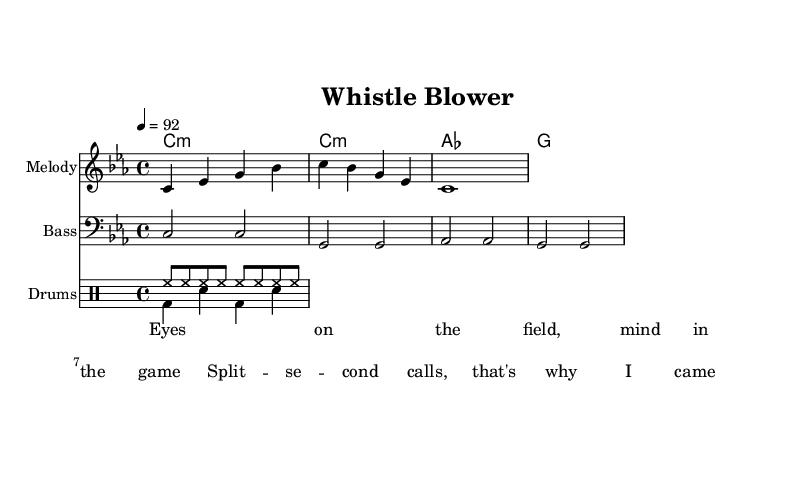What is the key signature of this music? The key signature indicates that the music is in C minor, as it is marked by the signature at the beginning with three flats (B flat, E flat, and A flat).
Answer: C minor What is the time signature of the piece? The time signature shows that the piece is written in 4/4 time, meaning there are four beats per measure, and the quarter note gets one beat. This is visible at the beginning of the music with the "4/4" notation.
Answer: 4/4 What is the tempo marking of the song? The tempo marking states that the piece should be played at a pace of 92 beats per minute. This is specified with "4 = 92" near the top of the sheet music.
Answer: 92 How many measures are in the melody section? The melody section comprises four measures, which can be counted by looking at the vertical lines separating the groupings of the notes in the sheet music.
Answer: 4 Which instrument plays the melody? The instrument specified to play the melody is labeled "Melody" at the beginning of its staff. This indicates it is the primary focus of this piece.
Answer: Melody What type of performance technique do the drums use? The drum part uses stated techniques such as hi-hat and bass drum patterns, which are typical in rap music to provide rhythmic drive and energy. This can be inferred from the usage of "hh" for hi-hat and "bd" for bass drum in the drum line.
Answer: Rhythmic drive Which theme does the lyric suggest the rap focuses on? The lyrics indicated deal with the theme of intense focus and decision-making under pressure in soccer, as reflected by phrases like "split-second calls." The content suggests a narrative about the urgency on the field.
Answer: Decision-making 